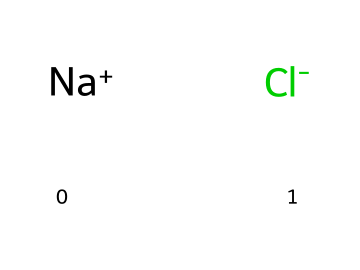What elements are present in this chemical? The SMILES notation indicates that there are sodium (Na) and chlorine (Cl) ions present.
Answer: sodium, chlorine How many atoms are in this chemical? The SMILES shows one sodium ion and one chlorine ion, totaling two atoms.
Answer: 2 What type of chemical interaction is represented here? Sodium and chlorine ions represent an ionic bond where sodium donates an electron to chlorine.
Answer: ionic bond What role do these ions play in sports drinks? Electrolytes like sodium and chloride help regulate hydration and electrolyte balance in sports drinks.
Answer: hydration, electrolyte balance Which ion is positively charged in this chemical? The sodium ion (Na+) is positively charged, as indicated by the plus sign in the SMILES representation.
Answer: sodium How can the presence of chlorine ions affect hydration? Chlorine, as part of sodium chloride, contributes to maintaining osmotic balance, which is crucial for hydration.
Answer: osmotic balance 